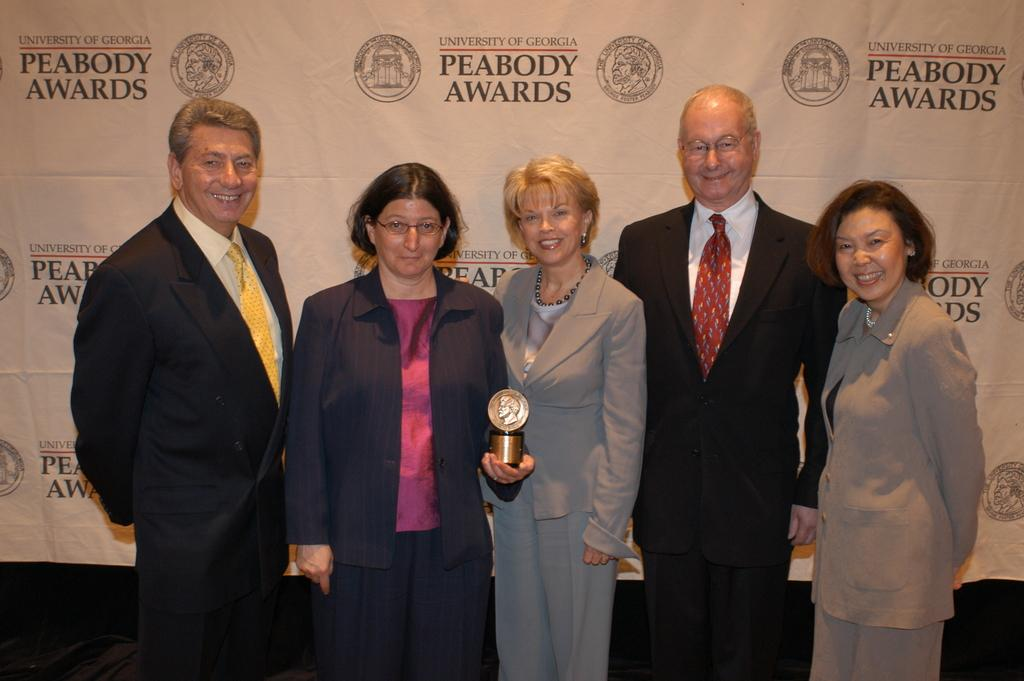How many people are in the image? There is a group of people in the image, but the exact number is not specified. What are the people doing in the image? The people are standing on a path. Can you describe the woman in the image? The woman is holding a trophy. What is visible behind the people in the image? There is a banner visible behind the people. What type of meat is being served on the feather in the image? There is no meat or feather present in the image. What type of business is being conducted in the image? The image does not depict any business activities. 